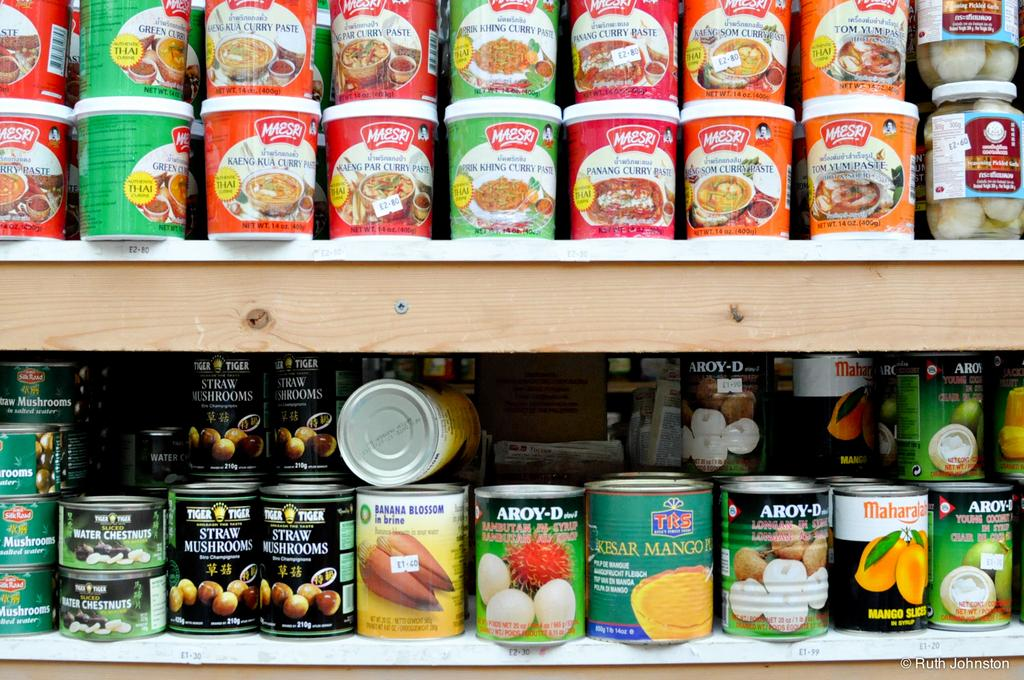How many wooden shelves are visible in the image? There are two wooden shelves in the image. What is stored on the wooden shelves? Many food can tins are stored on the shelves. What is the price of the basketball on the wooden shelves? There is no basketball present on the wooden shelves in the image. 